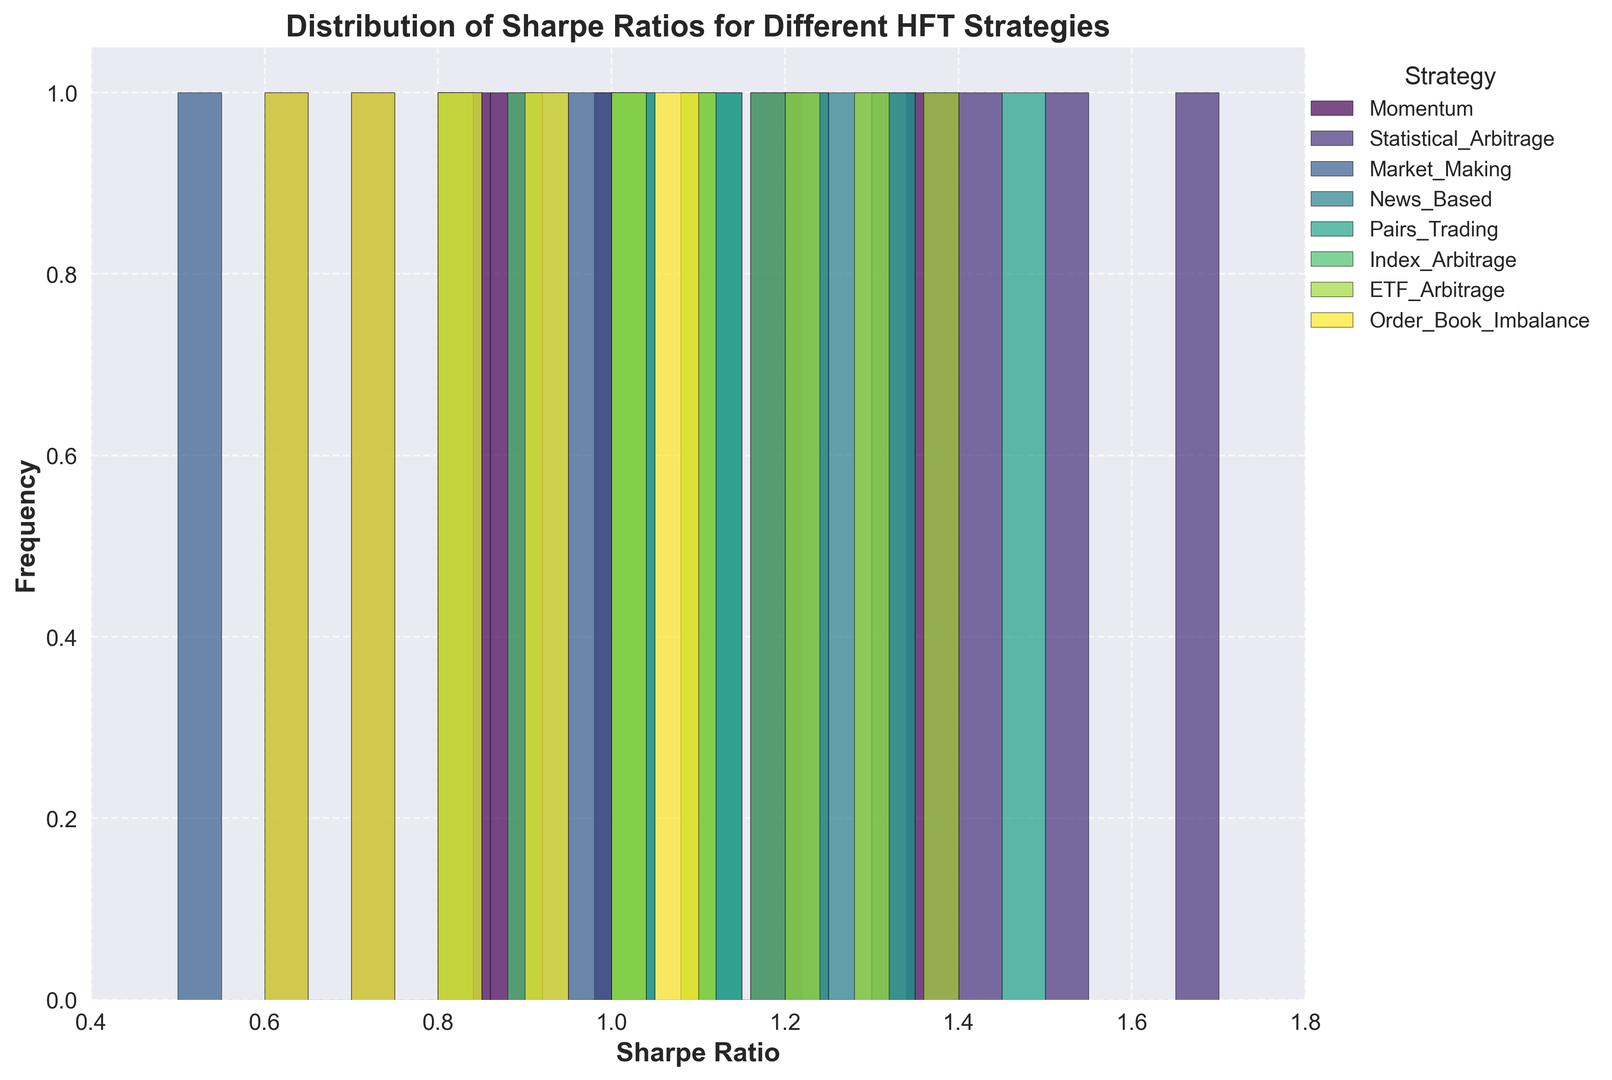What is the most frequent range of Sharpe ratios for the Market Making strategy? By looking at the histogram bars for Market Making, we can see which range of Sharpe ratios has the tallest bar indicating the highest frequency. The highest bar for Market Making is between 0.5 and 0.8.
Answer: 0.5 to 0.8 Which HFT strategy has the highest overall Sharpe ratio? We need to check the highest peak across all histograms. The Statistical Arbitrage and Pairs Trading strategies have peaks reaching up to the Sharpe ratio of 1.7 and 1.5, respectively. The highest peak goes to Statistical Arbitrage around 1.7 Sharpe ratio.
Answer: Statistical Arbitrage Between Momentum and ETF Arbitrage, which strategy tends to have higher Sharpe ratios? Comparing the histograms of Momentum and ETF Arbitrage, we notice that ETF Arbitrage's histogram is more concentrated in the higher range of Sharpe ratios from 1.0 to 1.4, whereas Momentum is more distributed with fewer higher peaks.
Answer: ETF Arbitrage What is the approximate average Sharpe ratio for Index Arbitrage, given the distribution? To find an approximate average, we observe the distribution of Sharpe ratios for Index Arbitrage. Most of the data points lie in the 0.8 to 1.2 range, approximately centering around 1.0.
Answer: 1.0 Compare the Sharpe ratios of Bear market conditions among all strategies; which strategy performs best? Analyzing the histogram's color segments that correspond to Sharpe ratios under Bear market conditions, we see that Statistical Arbitrage has the highest peak in Bear with Sharpe ratio around 1.3.
Answer: Statistical Arbitrage Which strategy has the narrowest distribution of Sharpe ratios and what does this indicate? A strategy with a narrow distribution will have bars within a limited Sharpe ratio range. Market Making shows a narrow distribution predominantly between 0.5 and 1.0, indicating less variance in its performance.
Answer: Market Making Is there a strategy where no Sharpe ratios fall below 0.8? Looking at the histograms, we notice that no Sharpe ratios for Statistical Arbitrage strategy fall below 0.8. All the bars for this strategy start from 1.2 and go upwards.
Answer: Statistical Arbitrage How does the Sharpe ratio of the News Based strategy compare in Bull vs. Bear markets? Observing the color-coded histogram sections for News Based strategy, it's evident that the Sharpe ratio in Bull markets (around 1.1) is slightly higher than in Bear markets (around 0.9).
Answer: Higher in Bull markets 